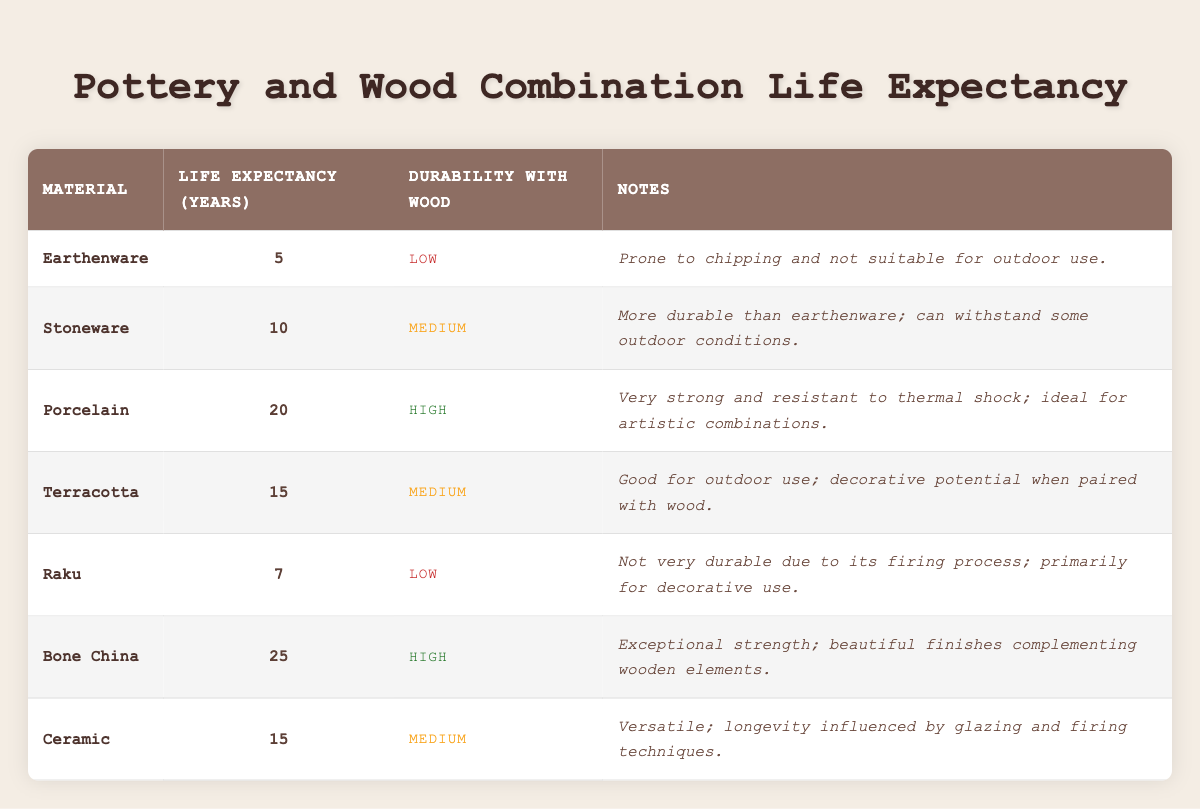What is the life expectancy of Bone China? According to the table, Bone China has a life expectancy of 25 years.
Answer: 25 years Which material has the highest durability when combined with wood? By checking the durability ratings, Porcelain and Bone China both have "High" durability when combined with wood.
Answer: Porcelain and Bone China What is the average life expectancy of the pottery materials listed? To find the average, we first add the life expectancies of all materials (5 + 10 + 20 + 15 + 7 + 25 + 15 = 97). Then, we divide by the number of materials (7), resulting in an average of approximately 13.86 years.
Answer: 13.86 years Is Stoneware suitable for outdoor use? The notes for Stoneware indicate that it can withstand some outdoor conditions, implying it is suitable for limited outdoor use.
Answer: Yes What is the difference in life expectancy between Porcelain and Raku? Porcelain has a life expectancy of 20 years, while Raku has 7 years. The difference is 20 - 7 = 13 years.
Answer: 13 years Which materials have a medium durability when combined with wood? Referring to the table, the materials listed with medium durability are Stoneware, Terracotta, and Ceramic.
Answer: Stoneware, Terracotta, Ceramic Is it true that Earthenware is more durable than Terracotta when combined with wood? The durability of Earthenware is rated as "Low," while Terracotta is rated as "Medium." Therefore, it is false that Earthenware is more durable than Terracotta.
Answer: No What is the total life expectancy of all the materials combined? We first sum all the life expectancies: 5 + 10 + 20 + 15 + 7 + 25 + 15 = 97 years, which is the total life expectancy of all materials combined.
Answer: 97 years 